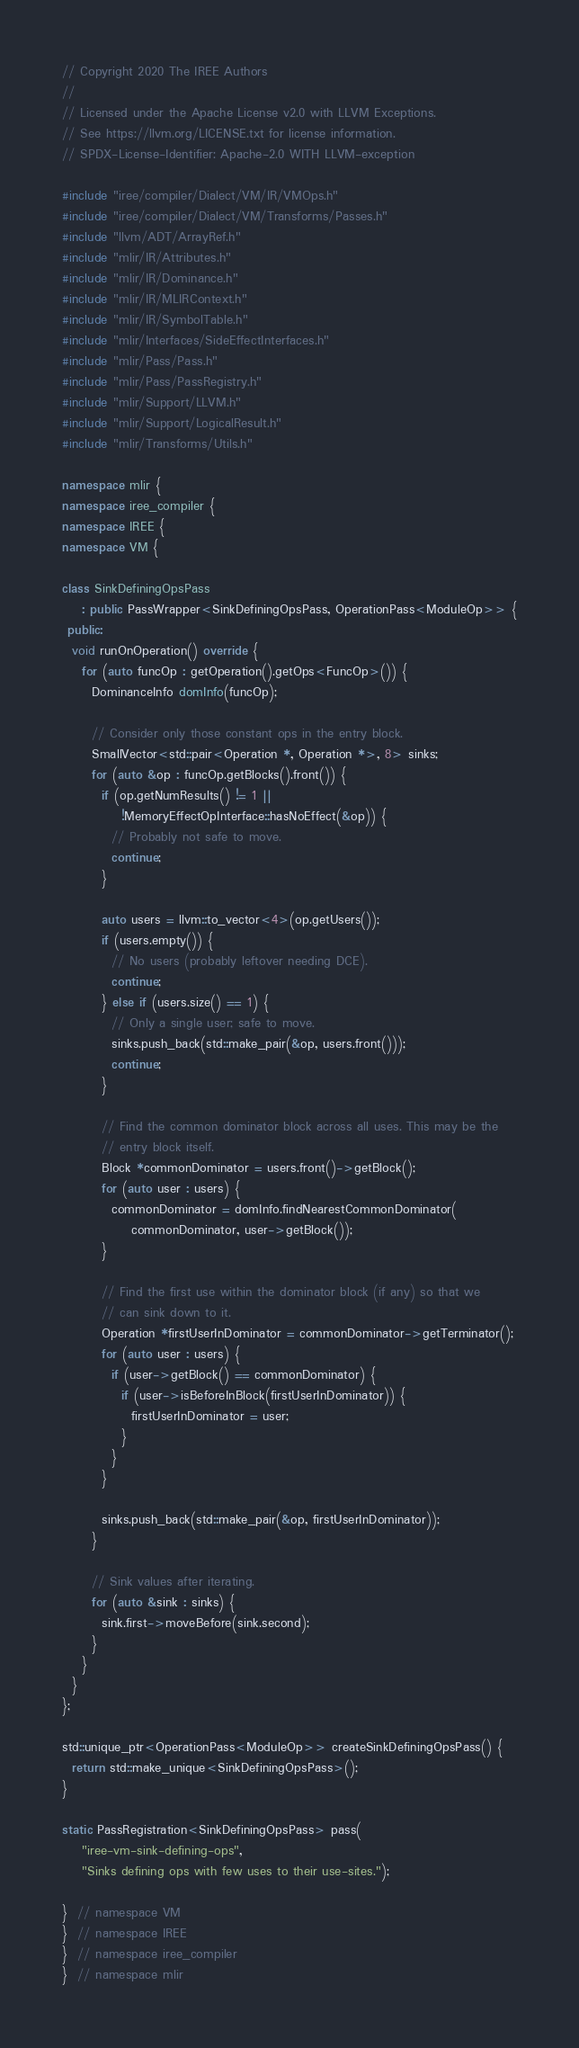<code> <loc_0><loc_0><loc_500><loc_500><_C++_>// Copyright 2020 The IREE Authors
//
// Licensed under the Apache License v2.0 with LLVM Exceptions.
// See https://llvm.org/LICENSE.txt for license information.
// SPDX-License-Identifier: Apache-2.0 WITH LLVM-exception

#include "iree/compiler/Dialect/VM/IR/VMOps.h"
#include "iree/compiler/Dialect/VM/Transforms/Passes.h"
#include "llvm/ADT/ArrayRef.h"
#include "mlir/IR/Attributes.h"
#include "mlir/IR/Dominance.h"
#include "mlir/IR/MLIRContext.h"
#include "mlir/IR/SymbolTable.h"
#include "mlir/Interfaces/SideEffectInterfaces.h"
#include "mlir/Pass/Pass.h"
#include "mlir/Pass/PassRegistry.h"
#include "mlir/Support/LLVM.h"
#include "mlir/Support/LogicalResult.h"
#include "mlir/Transforms/Utils.h"

namespace mlir {
namespace iree_compiler {
namespace IREE {
namespace VM {

class SinkDefiningOpsPass
    : public PassWrapper<SinkDefiningOpsPass, OperationPass<ModuleOp>> {
 public:
  void runOnOperation() override {
    for (auto funcOp : getOperation().getOps<FuncOp>()) {
      DominanceInfo domInfo(funcOp);

      // Consider only those constant ops in the entry block.
      SmallVector<std::pair<Operation *, Operation *>, 8> sinks;
      for (auto &op : funcOp.getBlocks().front()) {
        if (op.getNumResults() != 1 ||
            !MemoryEffectOpInterface::hasNoEffect(&op)) {
          // Probably not safe to move.
          continue;
        }

        auto users = llvm::to_vector<4>(op.getUsers());
        if (users.empty()) {
          // No users (probably leftover needing DCE).
          continue;
        } else if (users.size() == 1) {
          // Only a single user; safe to move.
          sinks.push_back(std::make_pair(&op, users.front()));
          continue;
        }

        // Find the common dominator block across all uses. This may be the
        // entry block itself.
        Block *commonDominator = users.front()->getBlock();
        for (auto user : users) {
          commonDominator = domInfo.findNearestCommonDominator(
              commonDominator, user->getBlock());
        }

        // Find the first use within the dominator block (if any) so that we
        // can sink down to it.
        Operation *firstUserInDominator = commonDominator->getTerminator();
        for (auto user : users) {
          if (user->getBlock() == commonDominator) {
            if (user->isBeforeInBlock(firstUserInDominator)) {
              firstUserInDominator = user;
            }
          }
        }

        sinks.push_back(std::make_pair(&op, firstUserInDominator));
      }

      // Sink values after iterating.
      for (auto &sink : sinks) {
        sink.first->moveBefore(sink.second);
      }
    }
  }
};

std::unique_ptr<OperationPass<ModuleOp>> createSinkDefiningOpsPass() {
  return std::make_unique<SinkDefiningOpsPass>();
}

static PassRegistration<SinkDefiningOpsPass> pass(
    "iree-vm-sink-defining-ops",
    "Sinks defining ops with few uses to their use-sites.");

}  // namespace VM
}  // namespace IREE
}  // namespace iree_compiler
}  // namespace mlir
</code> 